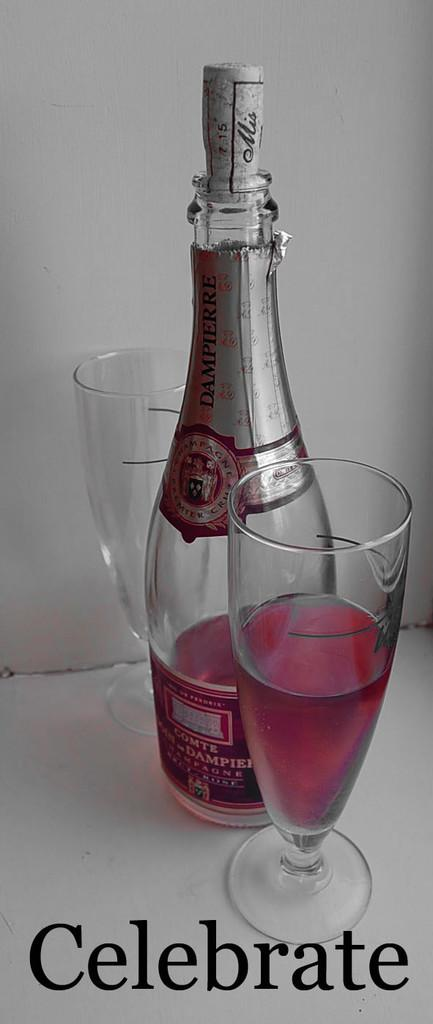<image>
Offer a succinct explanation of the picture presented. A BOTTLE OF PINK COMTE CHAMPAGNE AND HALF FULL GLASS 